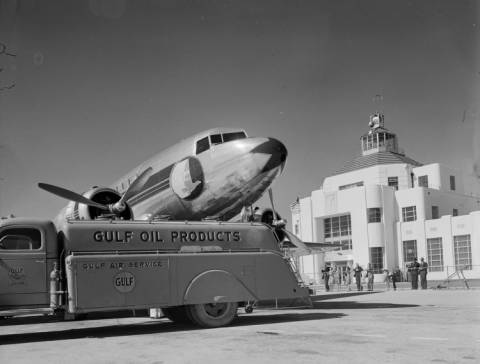Extract all visible text content from this image. GULF OIL PRODUCTS GULF GULF AIR 